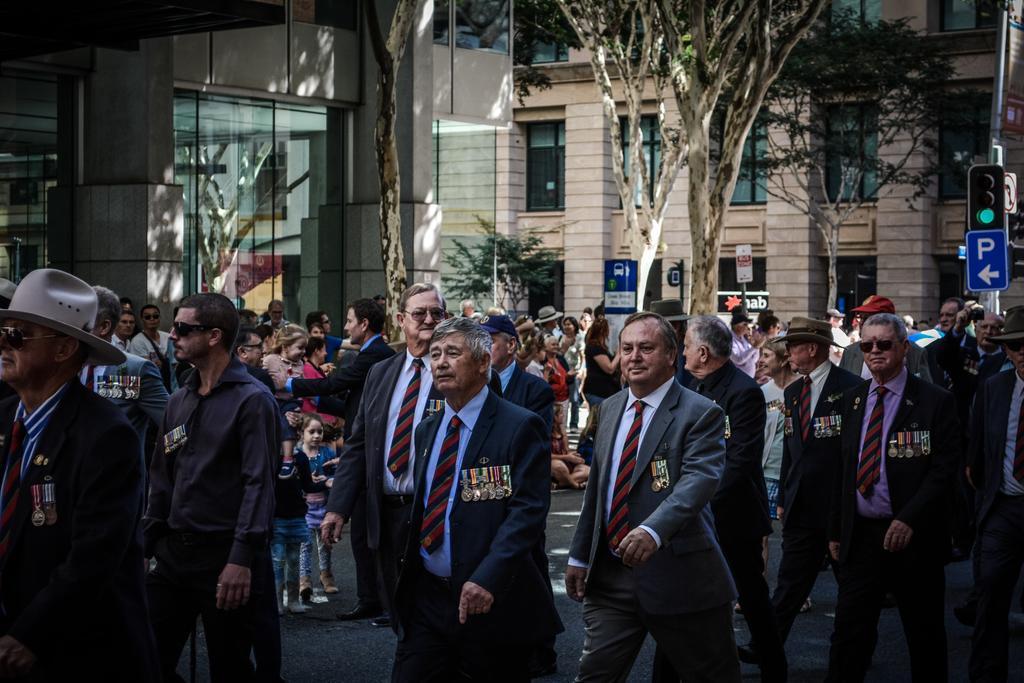Could you give a brief overview of what you see in this image? There are persons in different color dresses, walking on the road. In the background, there are other persons standing, sign boards, trees and buildings which are having glass windows. 